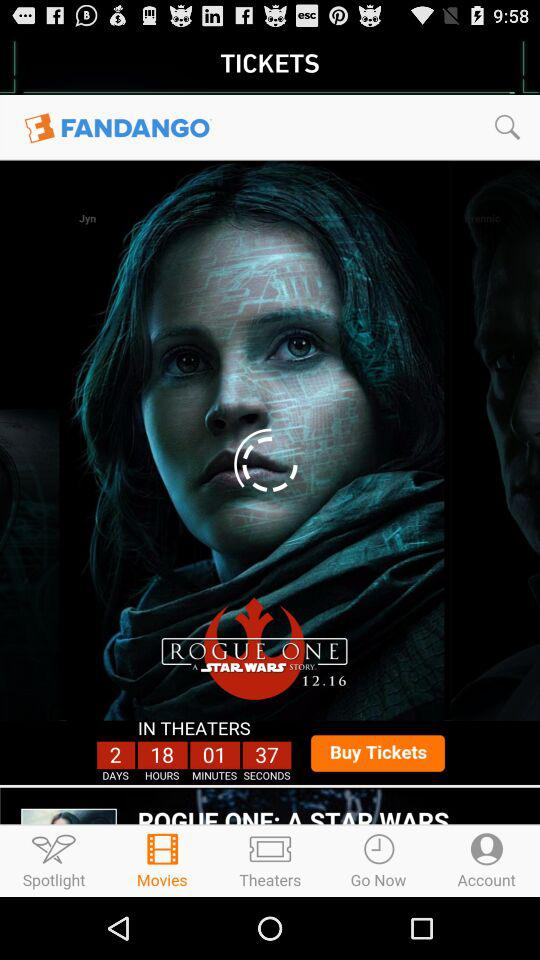What is the title of the movie? The title of the movie is "Rogue One: A Star Wars Story". 